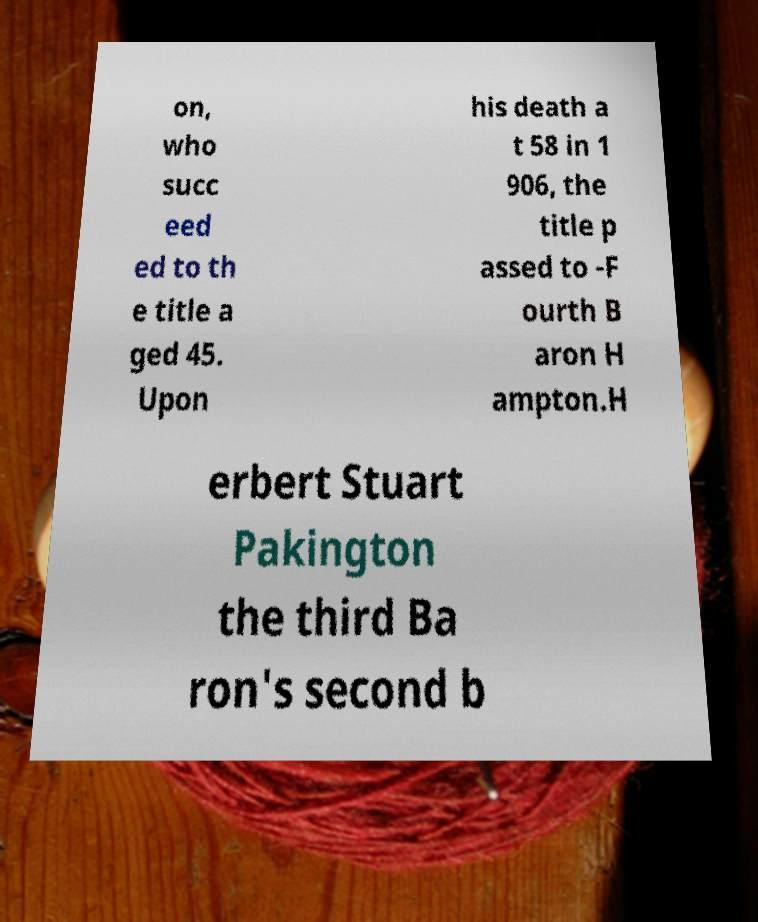Could you extract and type out the text from this image? on, who succ eed ed to th e title a ged 45. Upon his death a t 58 in 1 906, the title p assed to -F ourth B aron H ampton.H erbert Stuart Pakington the third Ba ron's second b 